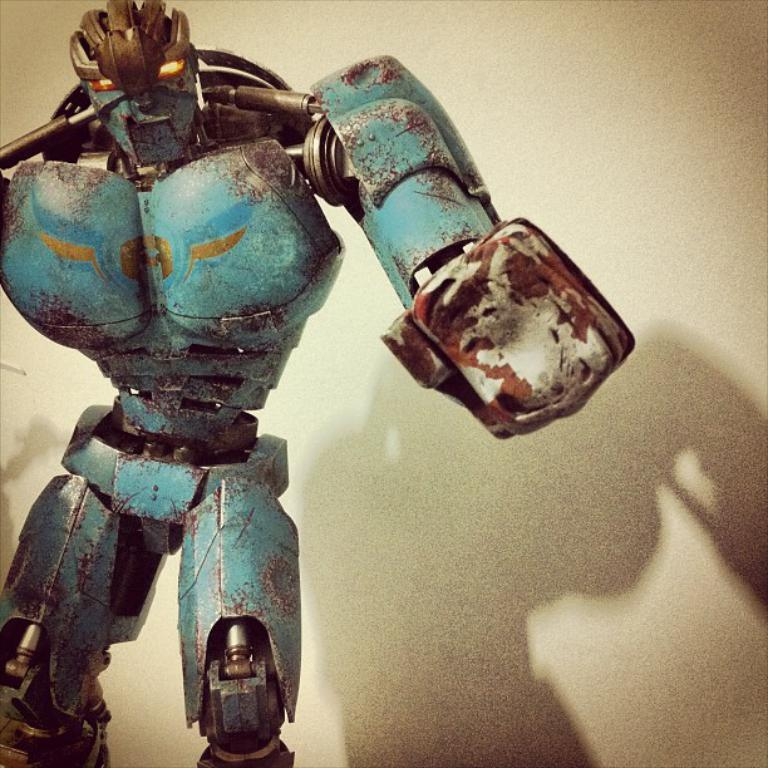What type of toy is in the image? There is an iron toy in the shape of a human in the image. What can be seen on the right side of the image? There is a wall on the right side of the image. Is the toy smiling in the image? There is no indication of the toy's facial expression in the image, so it cannot be determined if it is smiling. 